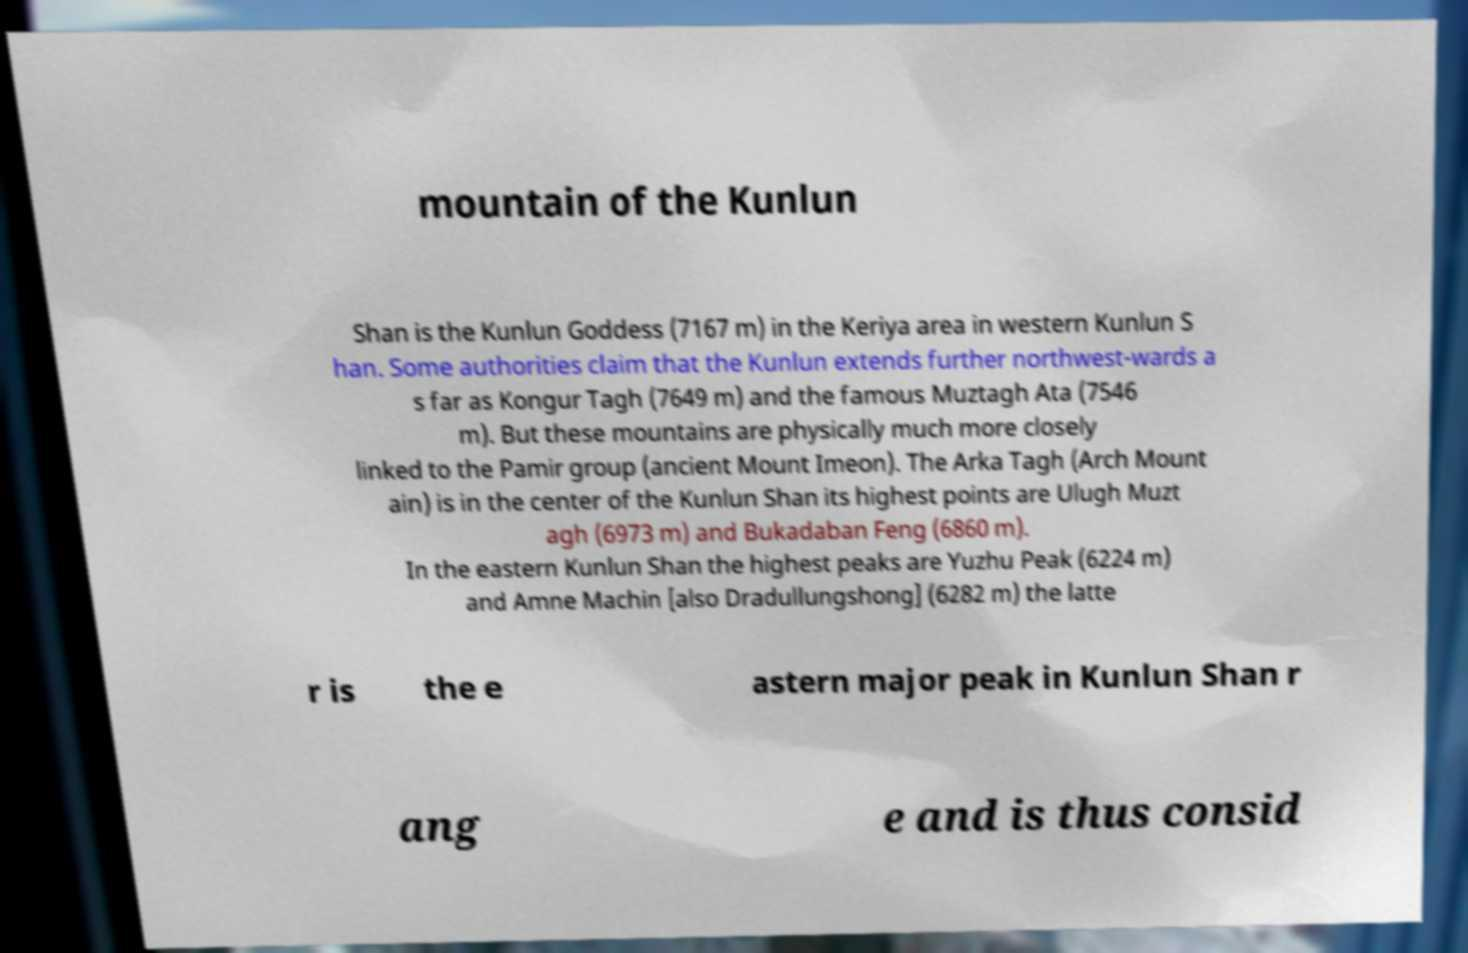I need the written content from this picture converted into text. Can you do that? mountain of the Kunlun Shan is the Kunlun Goddess (7167 m) in the Keriya area in western Kunlun S han. Some authorities claim that the Kunlun extends further northwest-wards a s far as Kongur Tagh (7649 m) and the famous Muztagh Ata (7546 m). But these mountains are physically much more closely linked to the Pamir group (ancient Mount Imeon). The Arka Tagh (Arch Mount ain) is in the center of the Kunlun Shan its highest points are Ulugh Muzt agh (6973 m) and Bukadaban Feng (6860 m). In the eastern Kunlun Shan the highest peaks are Yuzhu Peak (6224 m) and Amne Machin [also Dradullungshong] (6282 m) the latte r is the e astern major peak in Kunlun Shan r ang e and is thus consid 